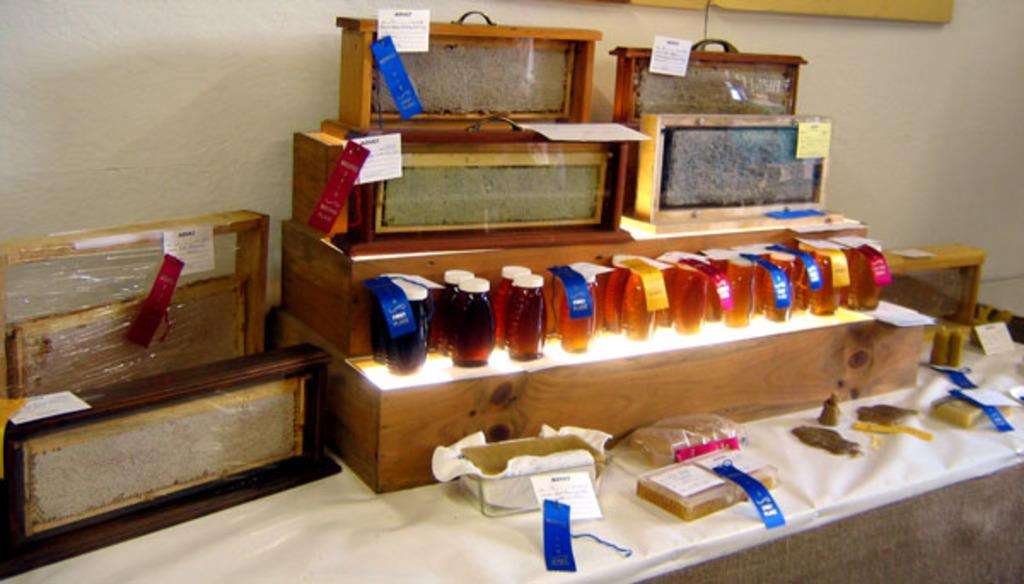What type of furniture is present in the image? There is a table in the image. How is the table decorated or covered? The table is covered with a cloth. What objects are placed on the table? There are wooden boxes and bottles with tags on the table. What can be seen in the background of the image? There is a wall visible in the image. What type of apple is being offered for selection in the image? There is no apple present in the image. What property is being sold in the image? There is no property being sold in the image. 